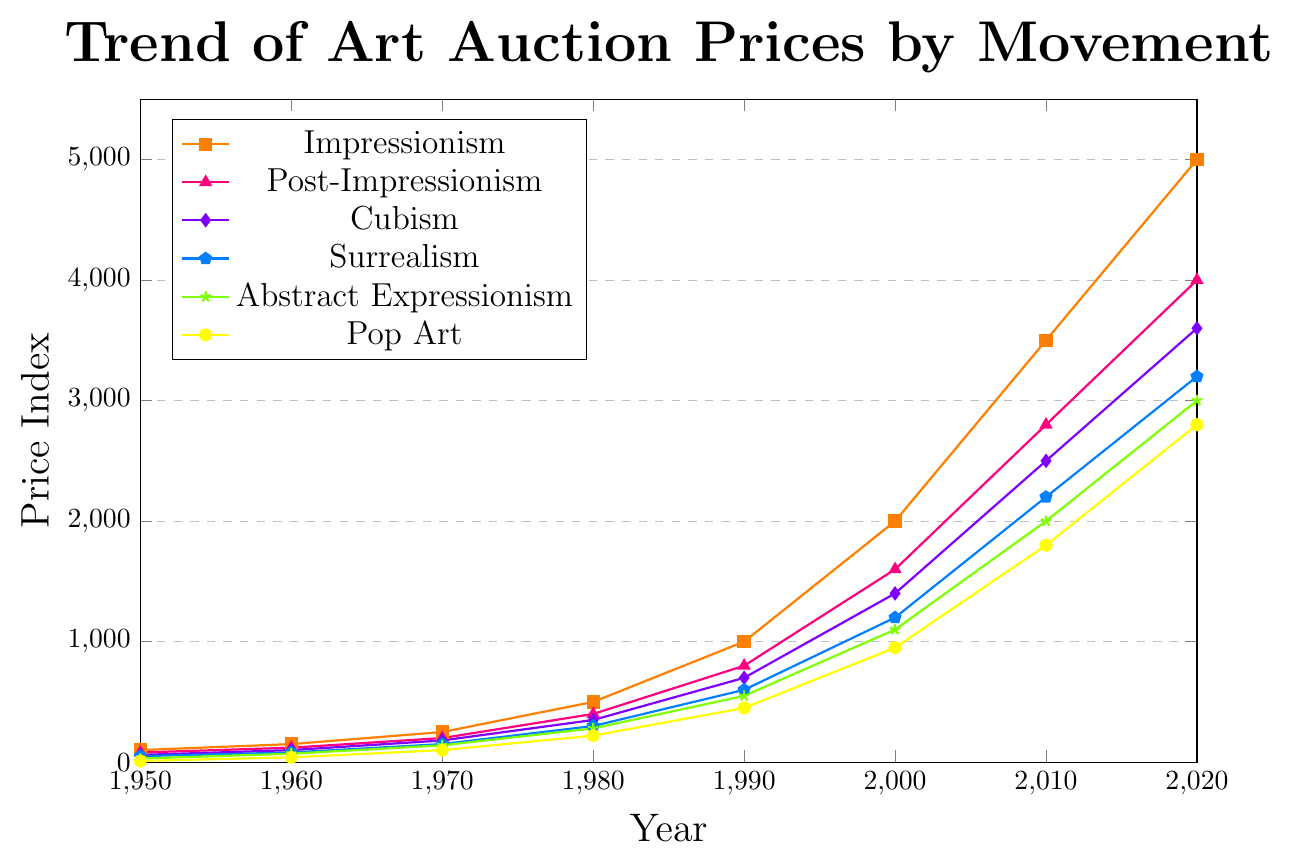Which artistic movement had the highest auction price in 2020? From the figure, the highest price point in 2020 is visible for Impressionism, as its line is the highest compared to other movements.
Answer: Impressionism How much did the price for Pop Art increase between 1950 and 2020? The price for Pop Art in 1950 was 10 and in 2020 it was 2800. Subtracting the former from the latter: 2800 - 10 = 2790.
Answer: 2790 Which two artistic movements showed the closest price index values in 2020? In 2020, the Surrealism and Abstract Expressionism movements had similar values of 3200 and 3000 respectively. They both lie close to each other in the upper range of the chart.
Answer: Surrealism and Abstract Expressionism What was the average auction price for Cubism during the decade of the 1960s? The values for Cubism in 1950 and 1970 are 60 and 180 respectively. To find an approximation for the average in the 1960s, we note that the trend appears somewhat linear between these two points, so we can average the two: (60 + 180) / 2 = 120.
Answer: 120 Which artistic movement had the fastest growth in auction price from 2000 to 2010? From 2000 to 2010, Impressionism grew from 2000 to 3500, an increase of 1500. Checking other movements' growth over the same period: Post-Impressionism (1600 to 2800, increase of 1200), Cubism (1400 to 2500, increase of 1100), Surrealism (1200 to 2200, increase of 1000), Abstract Expressionism (1100 to 2000, increase of 900), Pop Art (950 to 1800, increase of 850). Impressionism has the greatest increase.
Answer: Impressionism Compare the price trends for Impressionism and Surrealism over the entire period shown. How did their growth rates differ? Starting in 1950, Impressionism was at 100 and Surrealism at 50. By 2020, Impressionism reached 5000, while Surrealism reached 3200. Impressionism’s growth was 4900 and Surrealism’s 3150. Impressionism had a higher starting point and consistent larger increases, particularly notable after 1980. Surrealism’s growth was steady but less pronounced.
Answer: Impressionism grew faster than Surrealism What was the price index difference between Abstract Expressionism and Post-Impressionism in 1990? In 1990, the price index for Post-Impressionism was 800 and for Abstract Expressionism it was 550. The difference is: 800 - 550 = 250.
Answer: 250 Which periods show a marked increase in growth rate for Pop Art? Observing the Pop Art trend, the period from 1980 to 2000 shows a significant increase from 220 to 950. Another noticeable rise occurred from 2000 to 2020, where it increased to 2800.
Answer: 1980 to 2000 and 2000 to 2020 How did the growth in auction prices for Cubism from 1970 to 1980 compare to that of Abstract Expressionism in the same period? In 1970, Cubism was 180 and by 1980 it was 350, increasing by 170. For Abstract Expressionism, the price was 140 in 1970 and 280 in 1980, an increase of 140. Thus, Cubism grew more during this period: 170 vs. 140.
Answer: Cubism grew faster than Abstract Expressionism 